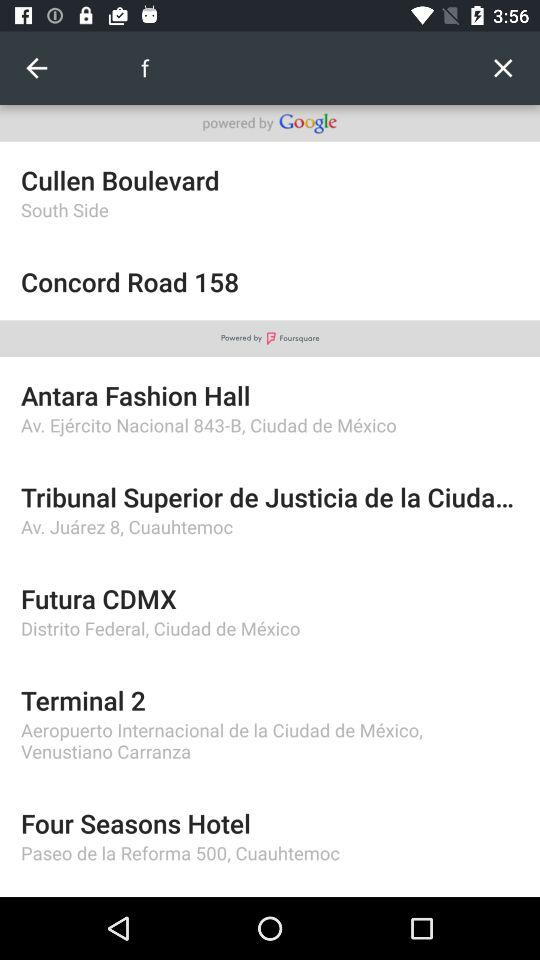What location is mentioned in "Futura CDMX"? The location is Distrito Federal, Ciudad de Mexico. 